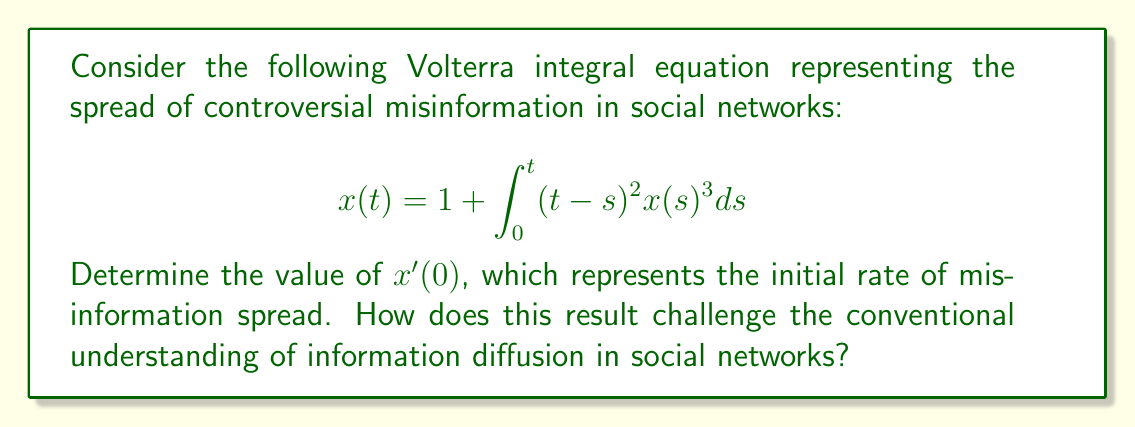Solve this math problem. To solve this problem and find $x'(0)$, we need to follow these steps:

1) First, we differentiate both sides of the equation with respect to $t$:

   $$\frac{d}{dt}x(t) = \frac{d}{dt}\left[1 + \int_0^t (t-s)^2 x(s)^3 ds\right]$$

2) Using the Leibniz integral rule, we get:

   $$x'(t) = \int_0^t \frac{\partial}{\partial t}[(t-s)^2 x(s)^3] ds + (t-t)^2 x(t)^3$$

3) Simplify:

   $$x'(t) = \int_0^t 2(t-s)x(s)^3 ds + 0$$

4) Now, we need to find $x'(0)$. When $t=0$, the integral disappears:

   $$x'(0) = \int_0^0 2(0-s)x(s)^3 ds = 0$$

5) Therefore, $x'(0) = 0$

This result challenges conventional understanding because it suggests that the initial rate of misinformation spread is zero, despite the presence of a non-zero initial condition ($x(0) = 1$). This implies that controversial misinformation might not immediately propagate in social networks, but could have a delayed onset of spread.

The cubic term $x(s)^3$ in the integral suggests that as misinformation grows, its spread accelerates non-linearly, potentially leading to explosive growth after the initial delay. This nuanced behavior contradicts simplistic models of information diffusion and highlights the complex dynamics of controversial content in social networks.
Answer: $x'(0) = 0$ 